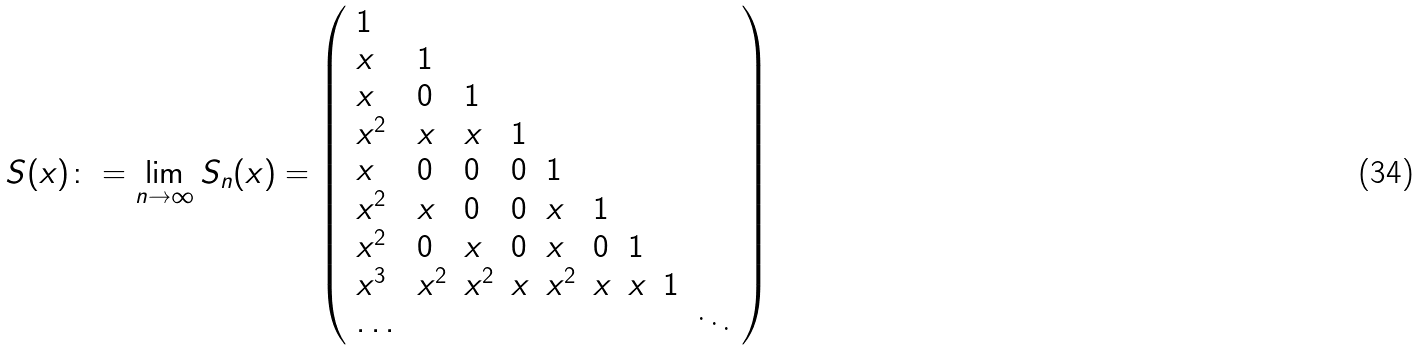<formula> <loc_0><loc_0><loc_500><loc_500>S ( x ) \colon = \lim _ { n \rightarrow \infty } S _ { n } ( x ) = \left ( \begin{array} { l l l l l l l l l } 1 \\ x & 1 \\ x & 0 & 1 \\ x ^ { 2 } & x & x & 1 \\ x & 0 & 0 & 0 & 1 \\ x ^ { 2 } & x & 0 & 0 & x & 1 \\ x ^ { 2 } & 0 & x & 0 & x & 0 & 1 \\ x ^ { 3 } & x ^ { 2 } & x ^ { 2 } & x & x ^ { 2 } & x & x & 1 \\ \dots & & & & & & & & \ddots \end{array} \right )</formula> 